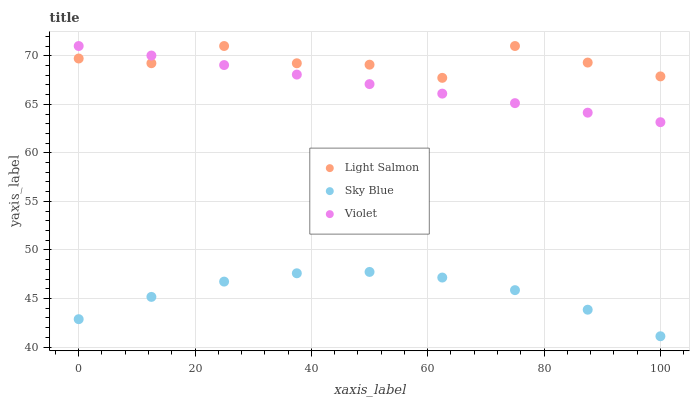Does Sky Blue have the minimum area under the curve?
Answer yes or no. Yes. Does Light Salmon have the maximum area under the curve?
Answer yes or no. Yes. Does Violet have the minimum area under the curve?
Answer yes or no. No. Does Violet have the maximum area under the curve?
Answer yes or no. No. Is Violet the smoothest?
Answer yes or no. Yes. Is Light Salmon the roughest?
Answer yes or no. Yes. Is Light Salmon the smoothest?
Answer yes or no. No. Is Violet the roughest?
Answer yes or no. No. Does Sky Blue have the lowest value?
Answer yes or no. Yes. Does Violet have the lowest value?
Answer yes or no. No. Does Violet have the highest value?
Answer yes or no. Yes. Is Sky Blue less than Light Salmon?
Answer yes or no. Yes. Is Violet greater than Sky Blue?
Answer yes or no. Yes. Does Violet intersect Light Salmon?
Answer yes or no. Yes. Is Violet less than Light Salmon?
Answer yes or no. No. Is Violet greater than Light Salmon?
Answer yes or no. No. Does Sky Blue intersect Light Salmon?
Answer yes or no. No. 